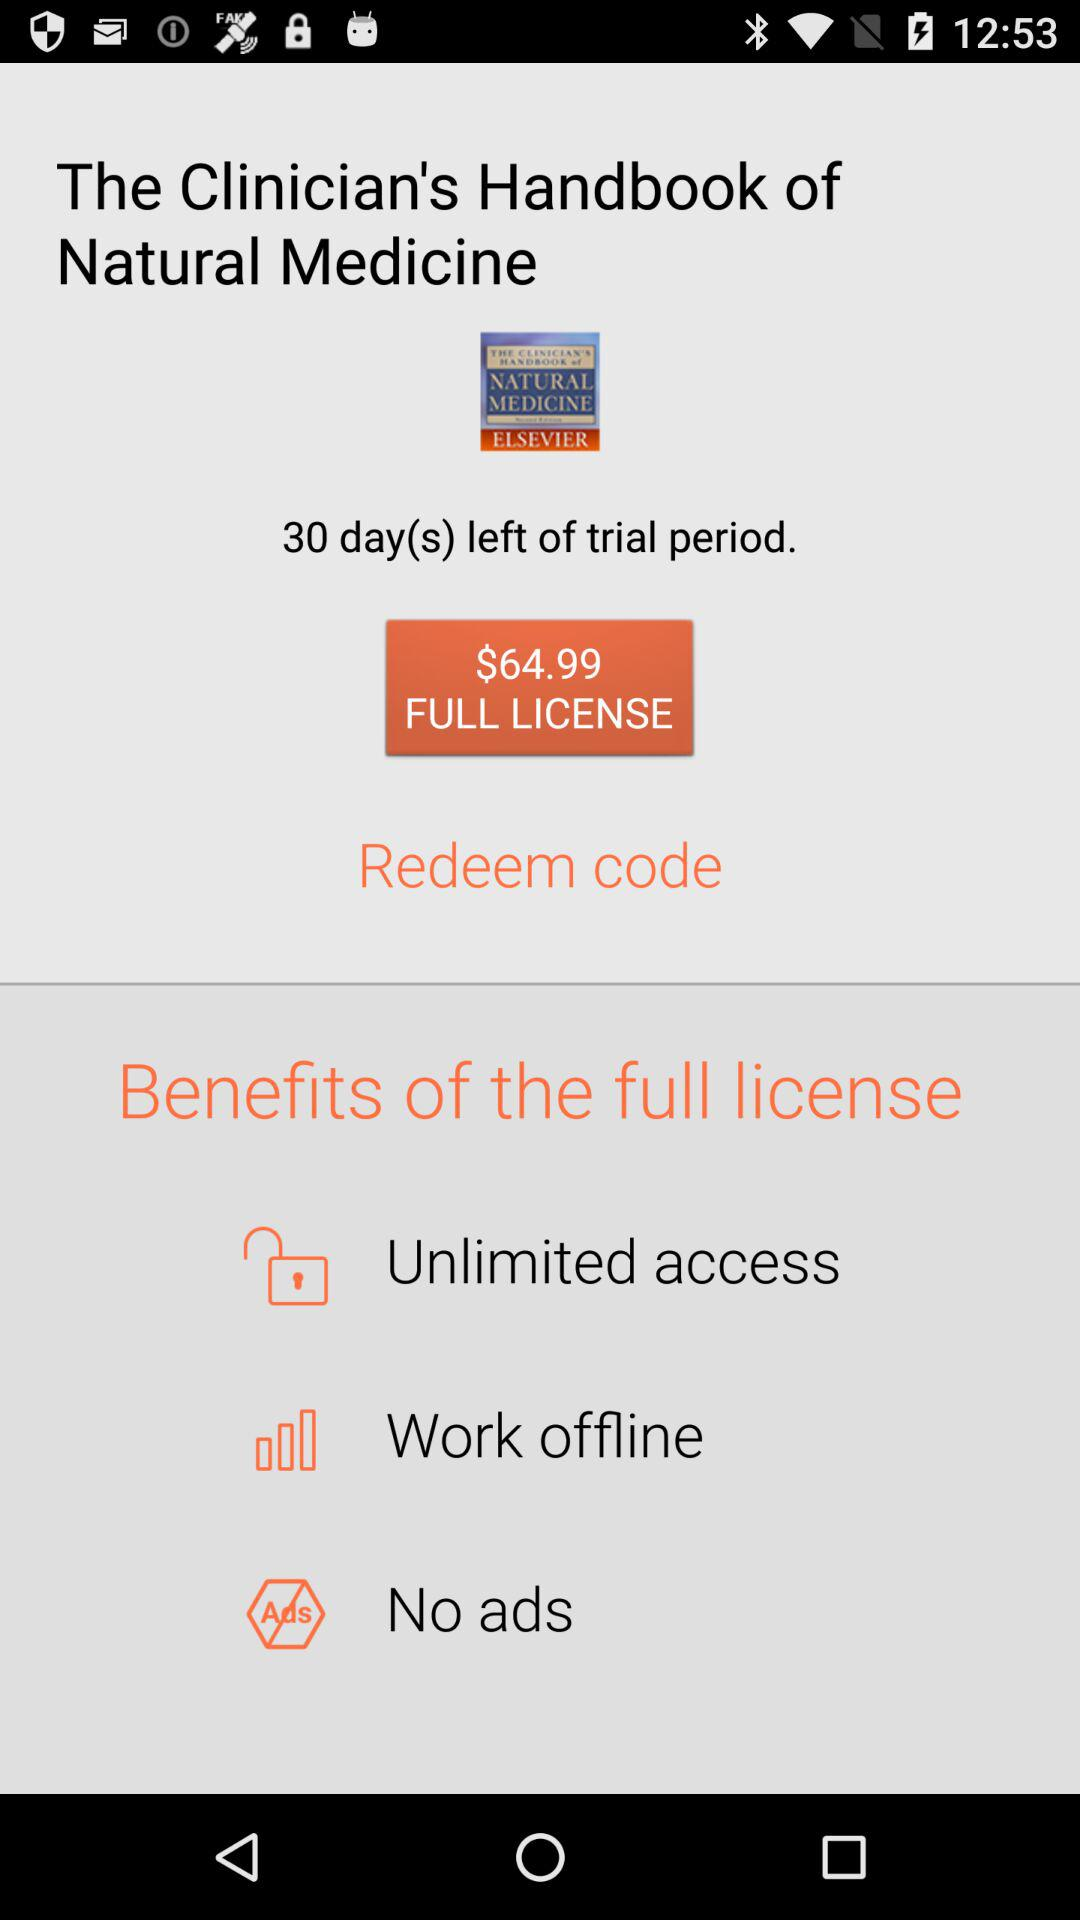What is the price of the full license version of "The Clinician's Handbook of Natural Medicine"? The price of the full license version is $64.99. 